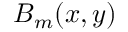Convert formula to latex. <formula><loc_0><loc_0><loc_500><loc_500>B _ { m } ( x , y )</formula> 